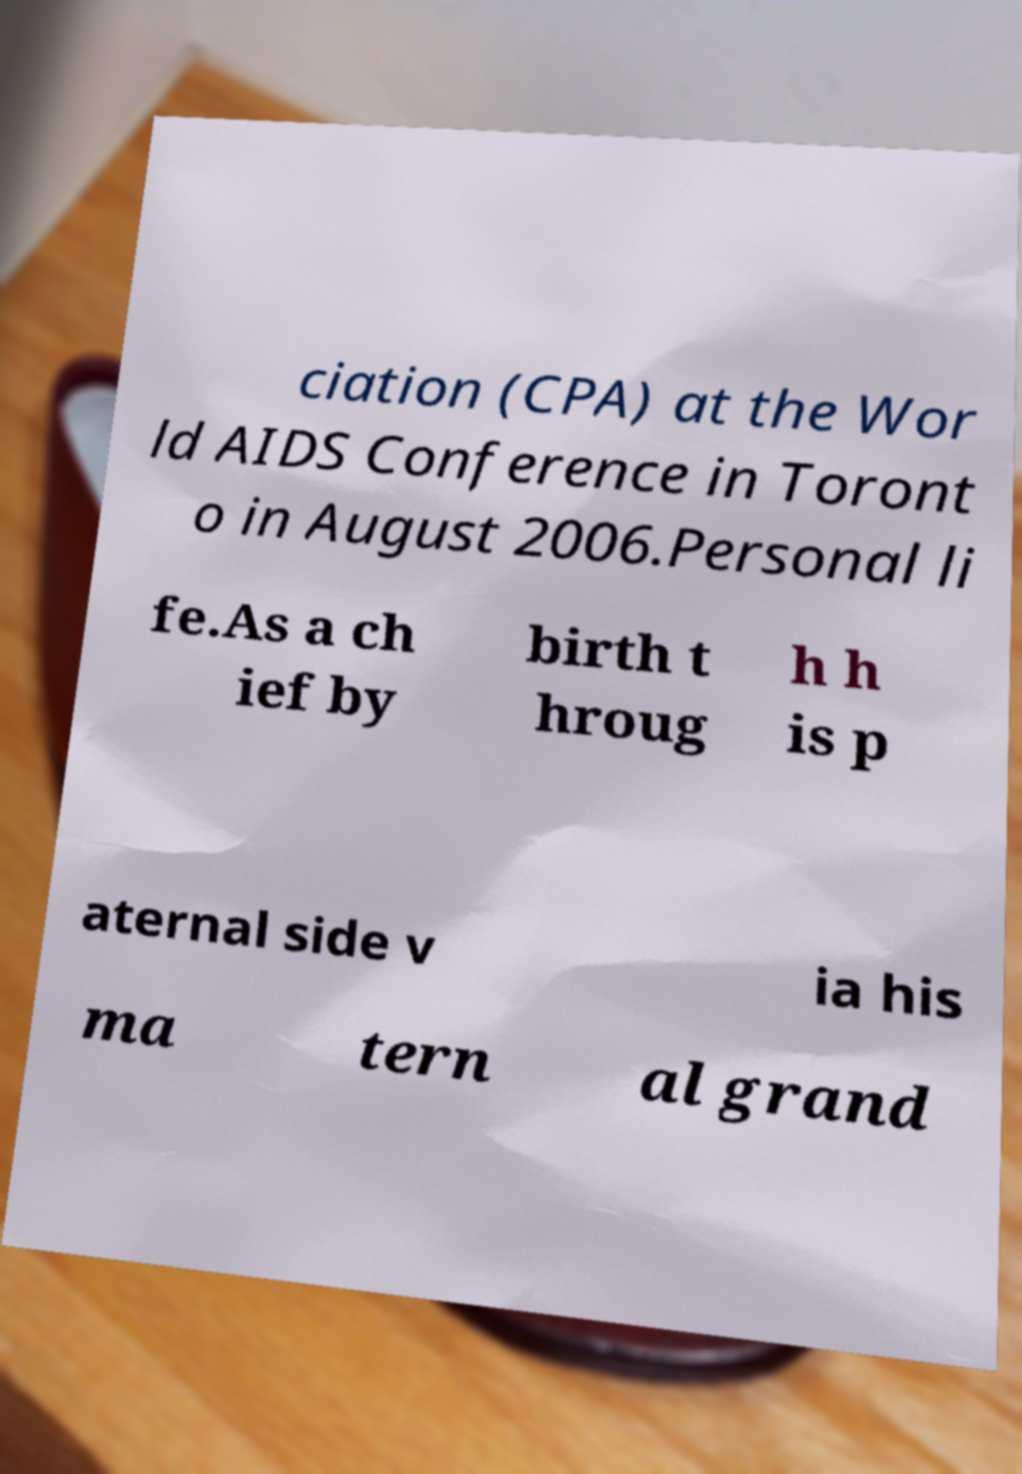There's text embedded in this image that I need extracted. Can you transcribe it verbatim? ciation (CPA) at the Wor ld AIDS Conference in Toront o in August 2006.Personal li fe.As a ch ief by birth t hroug h h is p aternal side v ia his ma tern al grand 